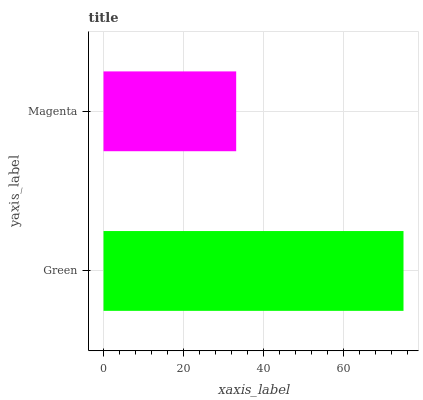Is Magenta the minimum?
Answer yes or no. Yes. Is Green the maximum?
Answer yes or no. Yes. Is Magenta the maximum?
Answer yes or no. No. Is Green greater than Magenta?
Answer yes or no. Yes. Is Magenta less than Green?
Answer yes or no. Yes. Is Magenta greater than Green?
Answer yes or no. No. Is Green less than Magenta?
Answer yes or no. No. Is Green the high median?
Answer yes or no. Yes. Is Magenta the low median?
Answer yes or no. Yes. Is Magenta the high median?
Answer yes or no. No. Is Green the low median?
Answer yes or no. No. 